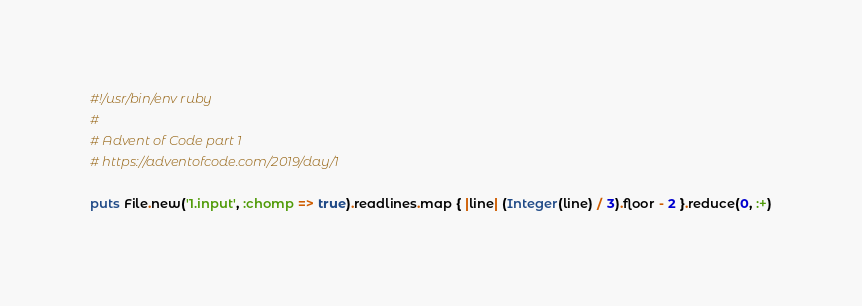<code> <loc_0><loc_0><loc_500><loc_500><_Ruby_>#!/usr/bin/env ruby
#
# Advent of Code part 1
# https://adventofcode.com/2019/day/1

puts File.new('1.input', :chomp => true).readlines.map { |line| (Integer(line) / 3).floor - 2 }.reduce(0, :+)
</code> 